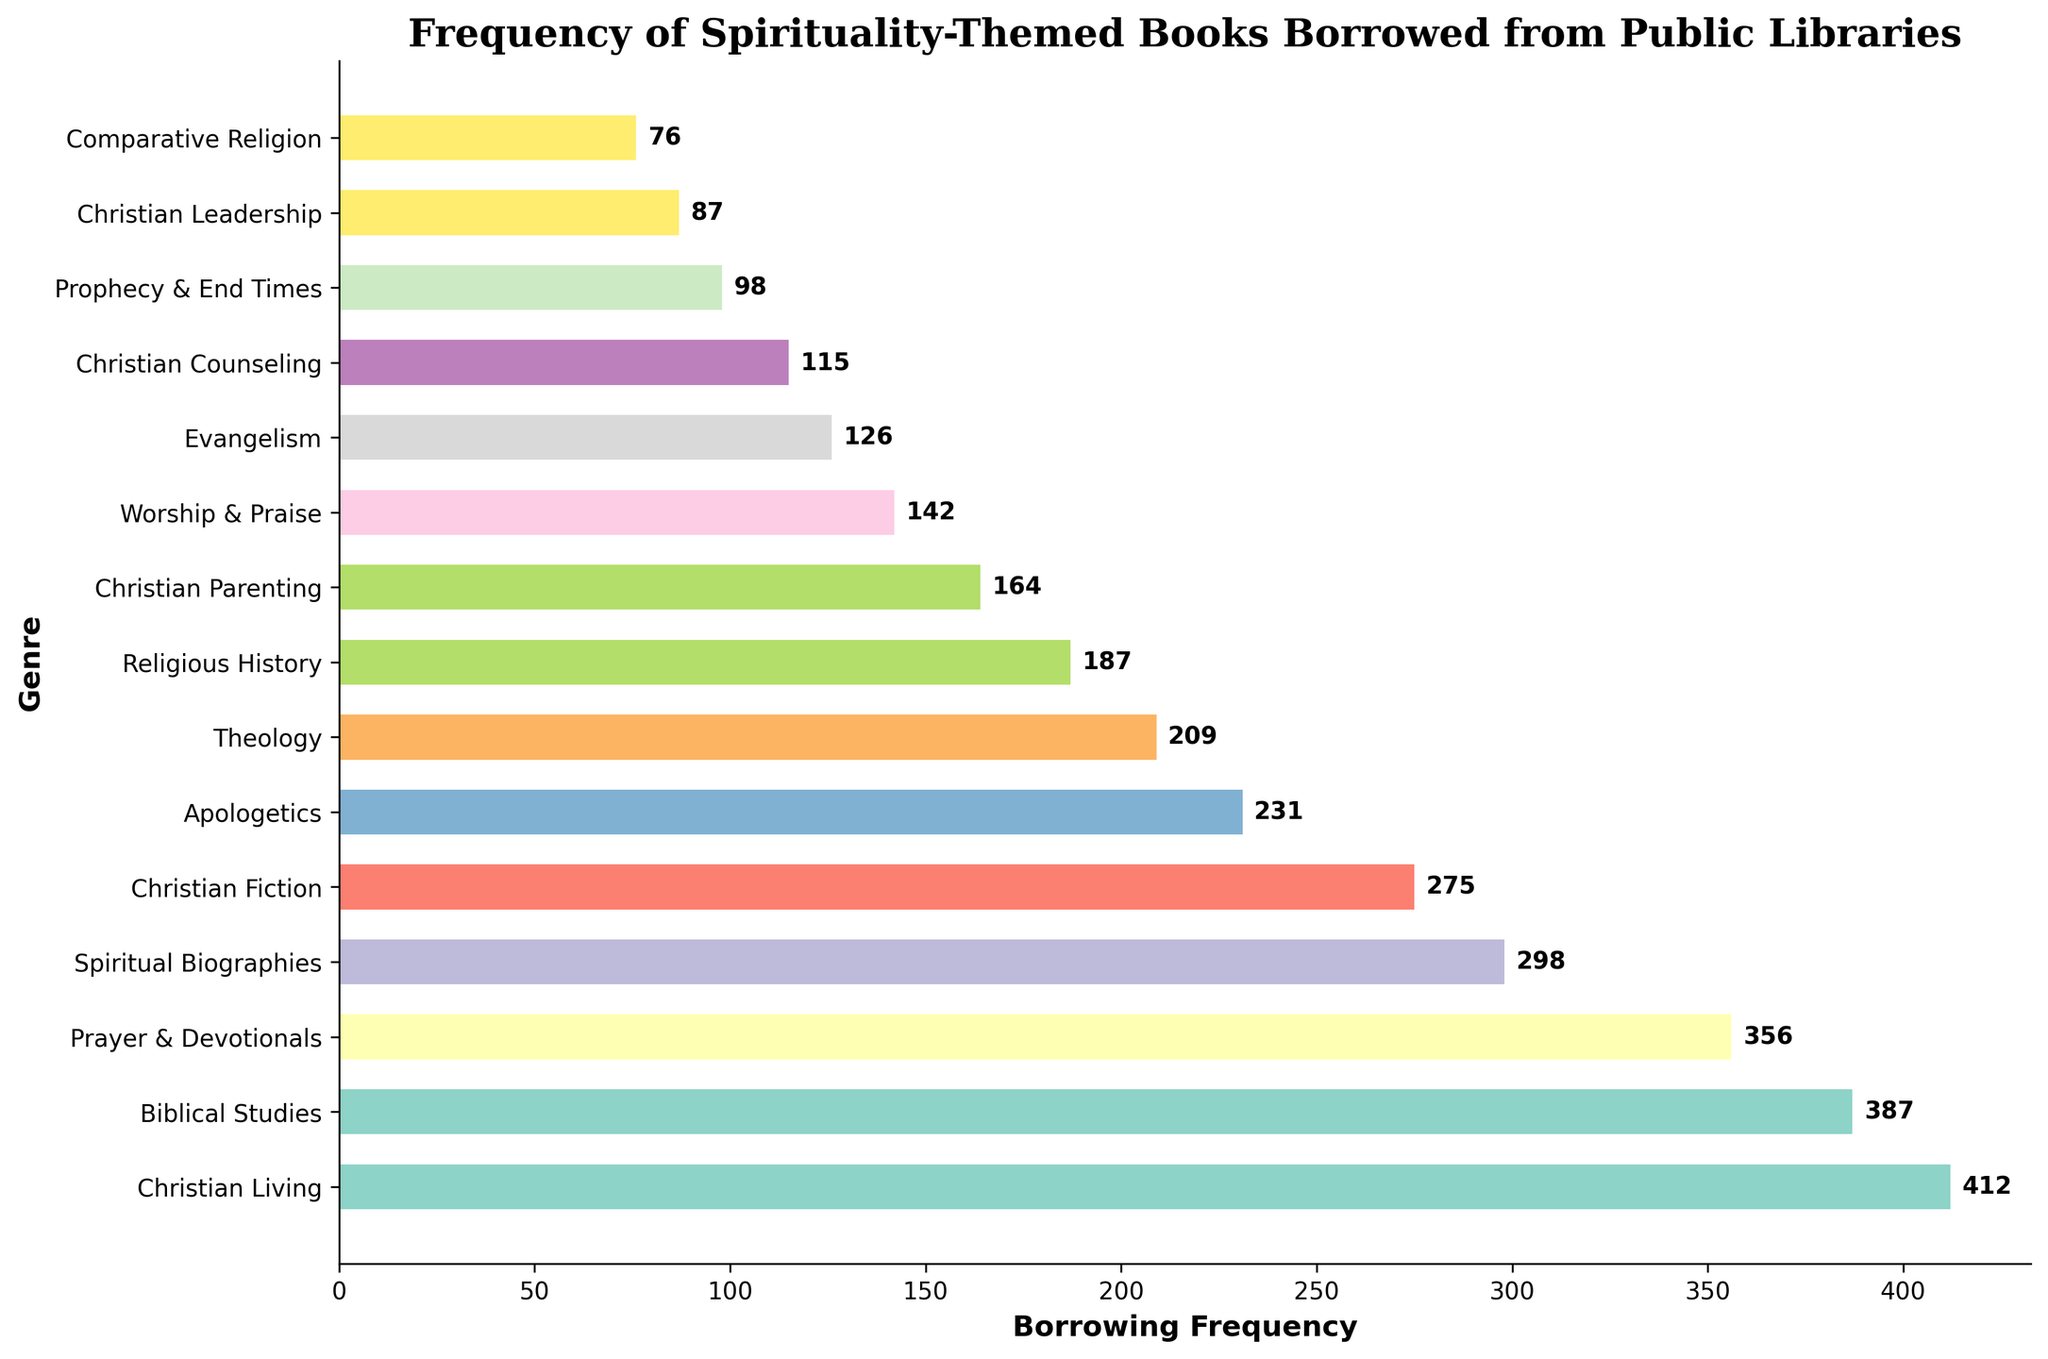What genre has the highest borrowing frequency? The genre with the highest borrowing frequency has the longest bar on the chart. By comparing the length of all bars, the longest one corresponds to "Christian Living".
Answer: Christian Living Which genre has a borrowing frequency closest to 300? By looking along the x-axis and comparing the bar lengths to the 300 mark, "Spiritual Biographies" has a borrowing frequency closest to 300.
Answer: Spiritual Biographies What is the combined borrowing frequency of "Christian Fiction" and "Biblical Studies"? The borrowing frequency for "Christian Fiction" is 275, and for "Biblical Studies" it is 387. Adding them together: 275 + 387 = 662.
Answer: 662 Is the borrowing frequency of "Prayer & Devotionals" more than "Apologetics"? Compare the lengths of the bars for "Prayer & Devotionals" (356) and "Apologetics" (231). The bar for "Prayer & Devotionals" is longer.
Answer: Yes What is the average borrowing frequency of the top three genres? The top three genres by borrowing frequency are "Christian Living" (412), "Biblical Studies" (387), and "Prayer & Devotionals" (356). Calculate the average: (412 + 387 + 356) / 3 = 1155 / 3 = 385.
Answer: 385 Which genre has a borrowing frequency exactly double that of "Christian Leadership"? The borrowing frequency of "Christian Leadership" is 87. Double that is 87 * 2 = 174. The genre with a borrowing frequency closest to 174 is "Christian Parenting" which is 164.
Answer: None Between "Worship & Praise" and "Evangelism", which has a higher borrowing frequency, and by how much? The bar for "Worship & Praise" shows a frequency of 142, while "Evangelism" has a frequency of 126. The difference is 142 - 126 = 16.
Answer: Worship & Praise, by 16 What proportion of the total borrowing frequency does "Theology" represent? First, sum all the borrowing frequencies to get the total: 412 + 387 + 356 + 298 + 275 + 231 + 209 + 187 + 164 + 142 + 126 + 115 + 98 + 87 + 76 = 3165. The borrowing frequency of "Theology" is 209. The proportion is 209 / 3165 ≈ 0.066 (or 6.6%).
Answer: 6.6% How many genres have a borrowing frequency greater than 300? Visual inspection shows that the genres "Christian Living" (412), "Biblical Studies" (387), and "Prayer & Devotionals" (356) all have frequencies greater than 300. Thus, the count is 3.
Answer: 3 Order "Prophecy & End Times", "Christian Leadership", and "Comparative Religion" by borrowing frequency from highest to lowest. The frequencies are: "Prophecy & End Times" (98), "Christian Leadership" (87), "Comparative Religion" (76). When ordered from highest to lowest, the order is: "Prophecy & End Times", "Christian Leadership", "Comparative Religion".
Answer: Prophecy & End Times, Christian Leadership, Comparative Religion 